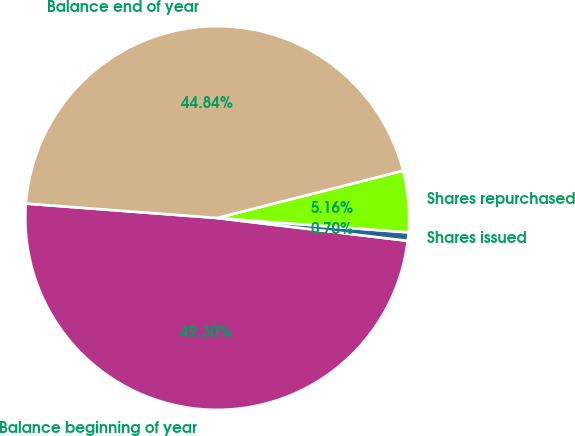Convert chart to OTSL. <chart><loc_0><loc_0><loc_500><loc_500><pie_chart><fcel>Balance beginning of year<fcel>Shares issued<fcel>Shares repurchased<fcel>Balance end of year<nl><fcel>49.3%<fcel>0.7%<fcel>5.16%<fcel>44.84%<nl></chart> 